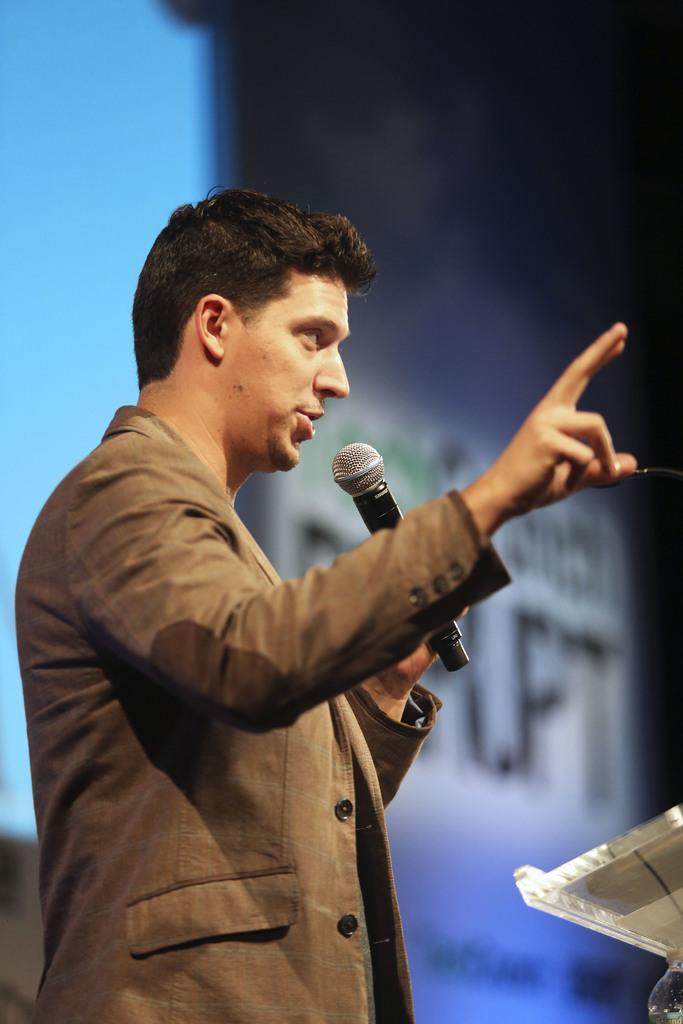Could you give a brief overview of what you see in this image? In this picture we can see a man in grey color jacket and holding a mike in his left hand and raising his right hand. 